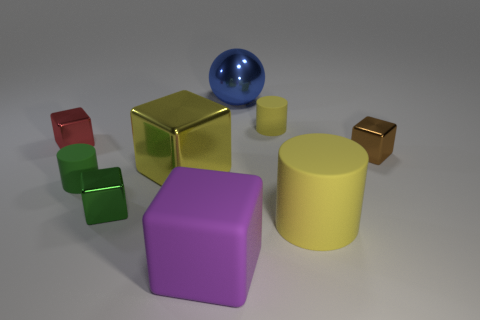There is a big shiny object that is the same shape as the tiny brown thing; what color is it?
Your response must be concise. Yellow. Are there fewer big things on the left side of the ball than large green rubber balls?
Your answer should be compact. No. Is there any other thing that is the same size as the brown cube?
Keep it short and to the point. Yes. There is a cube that is to the right of the big shiny object behind the small yellow thing; how big is it?
Provide a short and direct response. Small. Are there any other things that are the same shape as the green metallic object?
Your answer should be very brief. Yes. Is the number of green rubber things less than the number of brown metallic spheres?
Your answer should be very brief. No. There is a large thing that is both to the right of the big purple matte block and in front of the large blue metallic thing; what is its material?
Provide a succinct answer. Rubber. There is a tiny rubber cylinder to the left of the large sphere; is there a yellow rubber thing that is in front of it?
Provide a short and direct response. Yes. What number of objects are big yellow objects or large green balls?
Provide a succinct answer. 2. What shape is the metallic object that is both right of the purple matte block and to the left of the small yellow cylinder?
Your answer should be very brief. Sphere. 